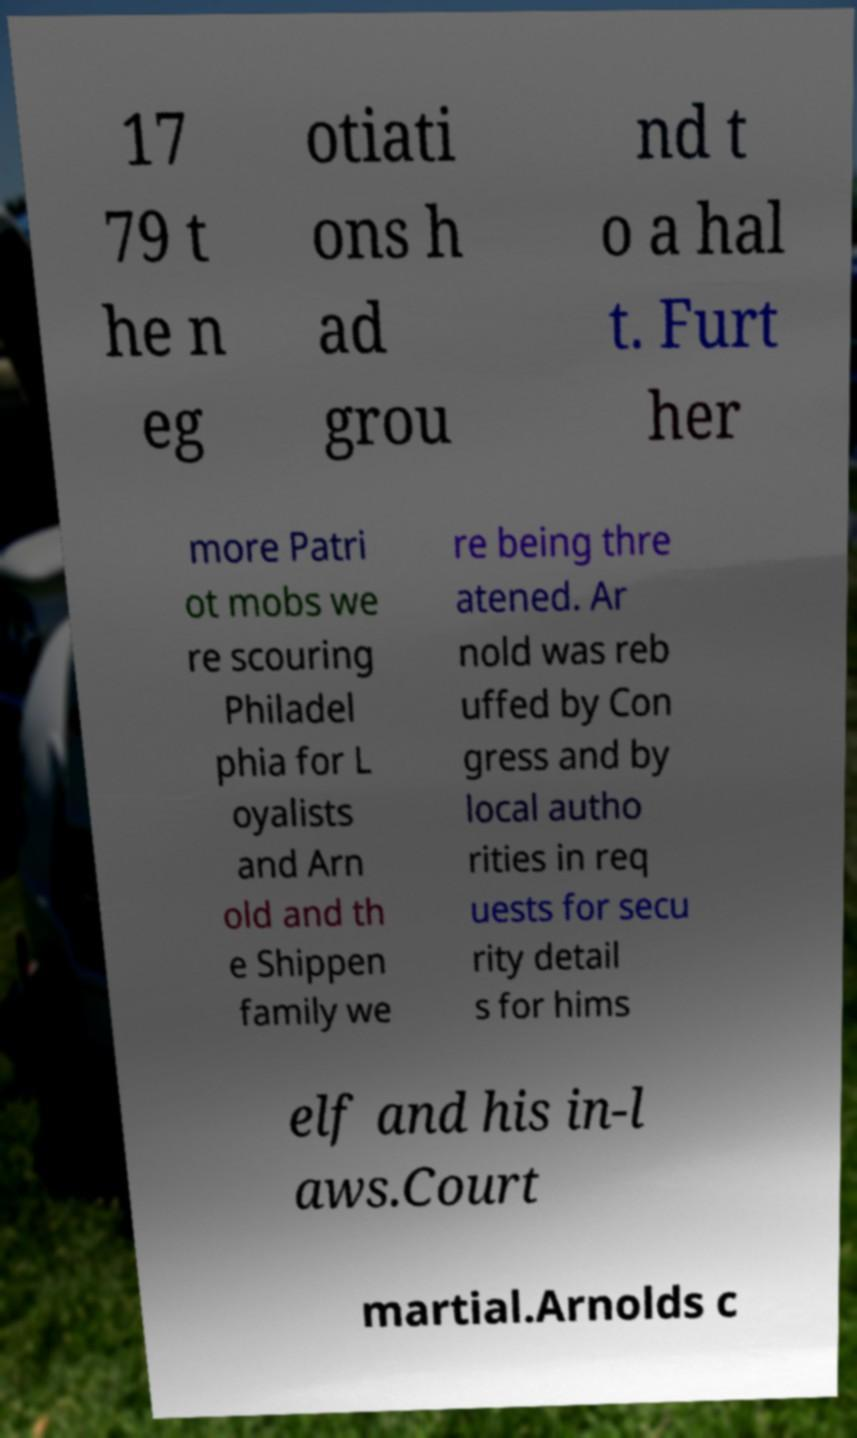I need the written content from this picture converted into text. Can you do that? 17 79 t he n eg otiati ons h ad grou nd t o a hal t. Furt her more Patri ot mobs we re scouring Philadel phia for L oyalists and Arn old and th e Shippen family we re being thre atened. Ar nold was reb uffed by Con gress and by local autho rities in req uests for secu rity detail s for hims elf and his in-l aws.Court martial.Arnolds c 